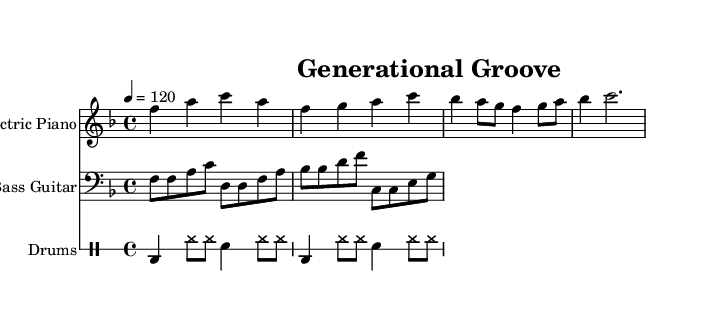What is the key signature of this music? The key signature is indicated by the absence of any sharps or flats in the beginning of the staff, signifying F major.
Answer: F major What is the time signature of this music? The time signature appears at the beginning of the piece, showing a 4 over 4, which means there are four beats in each measure.
Answer: 4/4 What is the tempo marking for this piece? The tempo is indicated at the beginning of the sheet music as "4 = 120", meaning there are 120 beats per minute.
Answer: 120 Which instrument plays the melody? The melody is played by the electric piano, which is specified in the staff name at the top of the electric piano part.
Answer: Electric Piano How many measures does the electric piano part contain? By counting the distinct groupings of notes and bars in the electric piano part, we see there are four measures in total.
Answer: 4 What kind of groove is displayed in the drums part? The drum part consists largely of bass drum and hi-hat patterns that contribute to a steady dance groove, typical of Disco music.
Answer: Dance groove What is the rhythmic pattern used in the drums part? The drumming consists of a bass drum played on the first beat, followed by hi-hat and snare, creating a syncopated driving rhythm characteristic of Disco.
Answer: Syncopated driving rhythm 